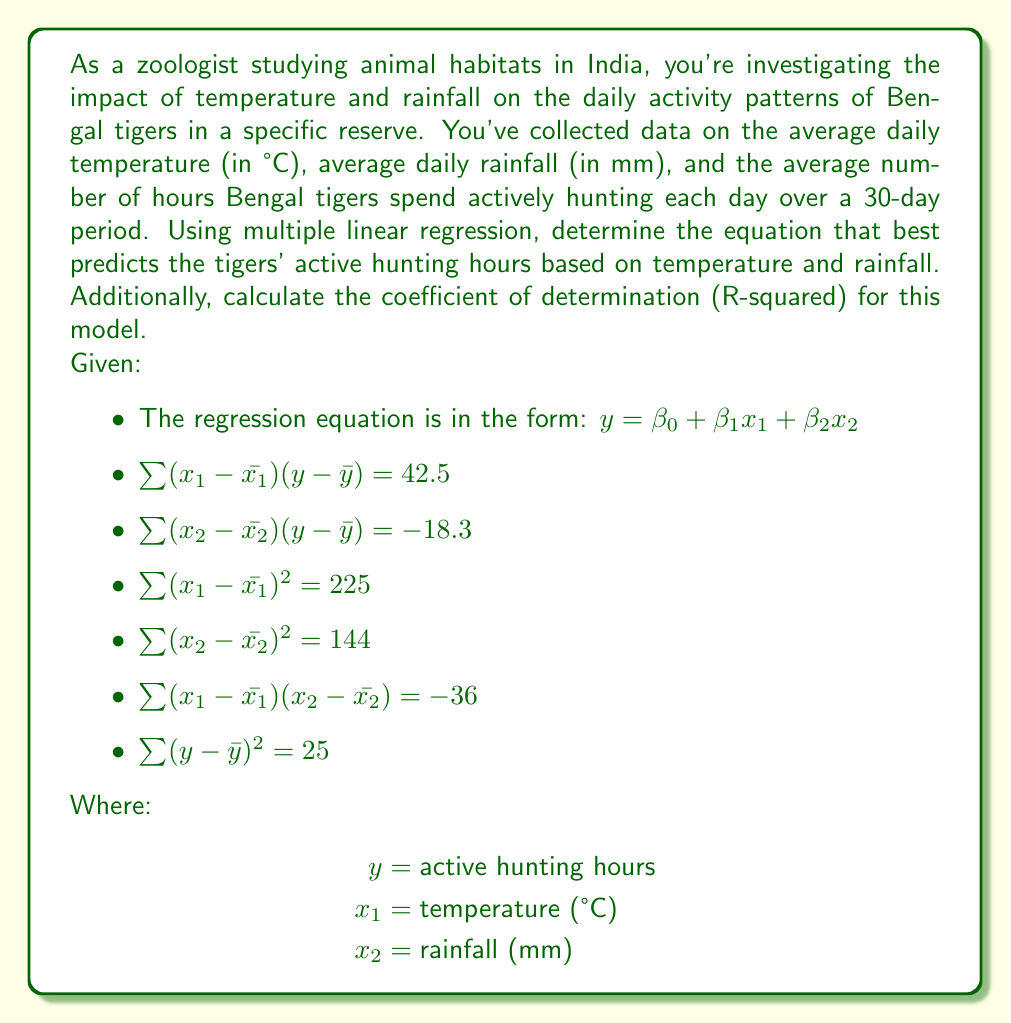Could you help me with this problem? To solve this problem, we'll follow these steps:

1. Calculate the regression coefficients $\beta_1$ and $\beta_2$
2. Determine $\beta_0$ (the y-intercept)
3. Calculate the coefficient of determination (R-squared)

Step 1: Calculate $\beta_1$ and $\beta_2$

We'll use the following formulas:

$$\beta_1 = \frac{\sum (x_1 - \bar{x_1})(y - \bar{y}) \sum (x_2 - \bar{x_2})^2 - \sum (x_2 - \bar{x_2})(y - \bar{y}) \sum (x_1 - \bar{x_1})(x_2 - \bar{x_2})}{\sum (x_1 - \bar{x_1})^2 \sum (x_2 - \bar{x_2})^2 - [\sum (x_1 - \bar{x_1})(x_2 - \bar{x_2})]^2}$$

$$\beta_2 = \frac{\sum (x_2 - \bar{x_2})(y - \bar{y}) \sum (x_1 - \bar{x_1})^2 - \sum (x_1 - \bar{x_1})(y - \bar{y}) \sum (x_1 - \bar{x_1})(x_2 - \bar{x_2})}{\sum (x_1 - \bar{x_1})^2 \sum (x_2 - \bar{x_2})^2 - [\sum (x_1 - \bar{x_1})(x_2 - \bar{x_2})]^2}$$

Substituting the given values:

$$\beta_1 = \frac{42.5 \times 144 - (-18.3) \times (-36)}{225 \times 144 - (-36)^2} = \frac{6120 - 658.8}{32400 - 1296} = \frac{5461.2}{31104} \approx 0.1756$$

$$\beta_2 = \frac{(-18.3) \times 225 - 42.5 \times (-36)}{225 \times 144 - (-36)^2} = \frac{-4117.5 - 1530}{31104} = \frac{-5647.5}{31104} \approx -0.1816$$

Step 2: Determine $\beta_0$ (the y-intercept)

We can't directly calculate $\beta_0$ without knowing the means of $x_1$, $x_2$, and $y$. However, we know that the regression line passes through the point $(\bar{x_1}, \bar{x_2}, \bar{y})$. So, we can express $\beta_0$ as:

$$\beta_0 = \bar{y} - \beta_1\bar{x_1} - \beta_2\bar{x_2}$$

Step 3: Calculate the coefficient of determination (R-squared)

R-squared is calculated using the formula:

$$R^2 = \frac{\text{SSR}}{\text{SST}} = 1 - \frac{\text{SSE}}{\text{SST}}$$

Where SST is the total sum of squares, which is given as $\sum (y - \bar{y})^2 = 25$.

SSR (sum of squares due to regression) can be calculated as:

$$\text{SSR} = \beta_1 \sum (x_1 - \bar{x_1})(y - \bar{y}) + \beta_2 \sum (x_2 - \bar{x_2})(y - \bar{y})$$

$$\text{SSR} = 0.1756 \times 42.5 + (-0.1816) \times (-18.3) = 7.463 + 3.323 = 10.786$$

Now we can calculate R-squared:

$$R^2 = \frac{10.786}{25} = 0.4314$$
Answer: The multiple linear regression equation is:

$y = \beta_0 + 0.1756x_1 - 0.1816x_2$

Where $\beta_0 = \bar{y} - 0.1756\bar{x_1} + 0.1816\bar{x_2}$

The coefficient of determination (R-squared) is 0.4314 or 43.14%. 